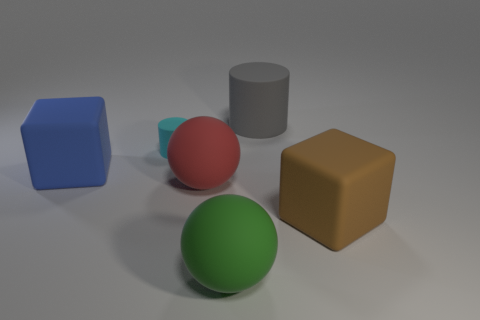Add 1 tiny cyan rubber blocks. How many objects exist? 7 Subtract all brown cubes. How many cubes are left? 1 Subtract 0 green blocks. How many objects are left? 6 Subtract 1 blocks. How many blocks are left? 1 Subtract all blue blocks. Subtract all yellow spheres. How many blocks are left? 1 Subtract all blue blocks. How many blue balls are left? 0 Subtract all big rubber blocks. Subtract all gray rubber things. How many objects are left? 3 Add 4 cyan matte cylinders. How many cyan matte cylinders are left? 5 Add 1 small cylinders. How many small cylinders exist? 2 